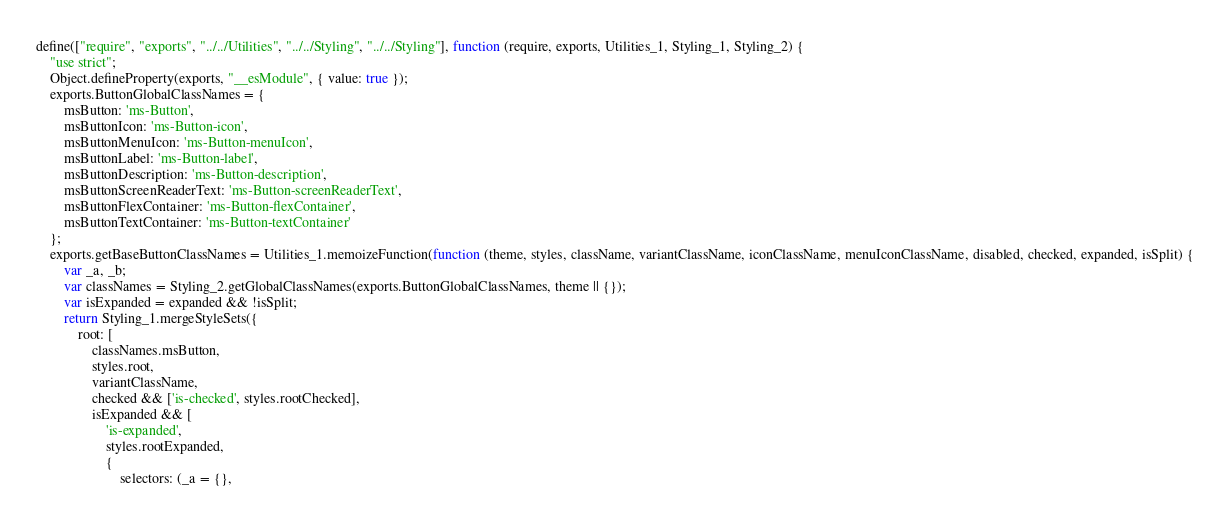Convert code to text. <code><loc_0><loc_0><loc_500><loc_500><_JavaScript_>define(["require", "exports", "../../Utilities", "../../Styling", "../../Styling"], function (require, exports, Utilities_1, Styling_1, Styling_2) {
    "use strict";
    Object.defineProperty(exports, "__esModule", { value: true });
    exports.ButtonGlobalClassNames = {
        msButton: 'ms-Button',
        msButtonIcon: 'ms-Button-icon',
        msButtonMenuIcon: 'ms-Button-menuIcon',
        msButtonLabel: 'ms-Button-label',
        msButtonDescription: 'ms-Button-description',
        msButtonScreenReaderText: 'ms-Button-screenReaderText',
        msButtonFlexContainer: 'ms-Button-flexContainer',
        msButtonTextContainer: 'ms-Button-textContainer'
    };
    exports.getBaseButtonClassNames = Utilities_1.memoizeFunction(function (theme, styles, className, variantClassName, iconClassName, menuIconClassName, disabled, checked, expanded, isSplit) {
        var _a, _b;
        var classNames = Styling_2.getGlobalClassNames(exports.ButtonGlobalClassNames, theme || {});
        var isExpanded = expanded && !isSplit;
        return Styling_1.mergeStyleSets({
            root: [
                classNames.msButton,
                styles.root,
                variantClassName,
                checked && ['is-checked', styles.rootChecked],
                isExpanded && [
                    'is-expanded',
                    styles.rootExpanded,
                    {
                        selectors: (_a = {},</code> 